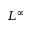Convert formula to latex. <formula><loc_0><loc_0><loc_500><loc_500>L ^ { \infty }</formula> 